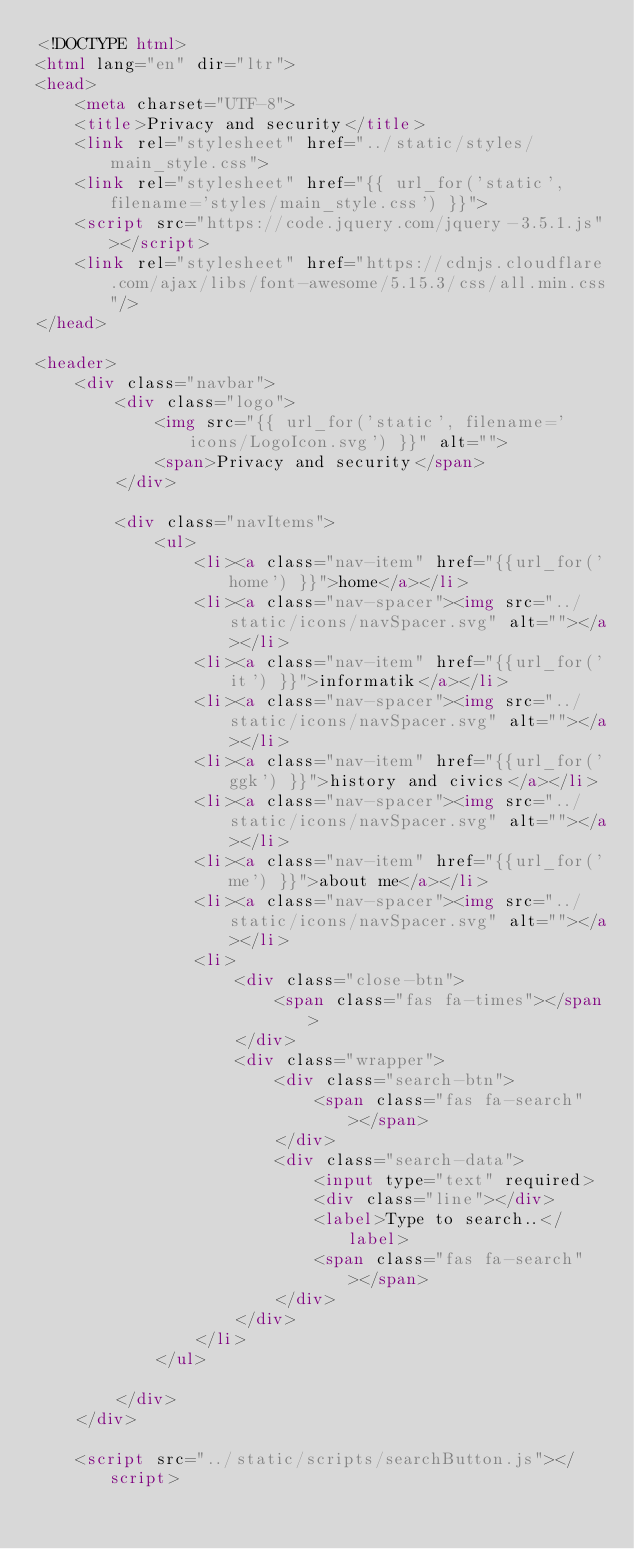Convert code to text. <code><loc_0><loc_0><loc_500><loc_500><_HTML_><!DOCTYPE html>
<html lang="en" dir="ltr">
<head>
    <meta charset="UTF-8">
    <title>Privacy and security</title>
    <link rel="stylesheet" href="../static/styles/main_style.css">
    <link rel="stylesheet" href="{{ url_for('static', filename='styles/main_style.css') }}">
    <script src="https://code.jquery.com/jquery-3.5.1.js"></script>
    <link rel="stylesheet" href="https://cdnjs.cloudflare.com/ajax/libs/font-awesome/5.15.3/css/all.min.css"/>
</head>

<header>
    <div class="navbar">
        <div class="logo">
            <img src="{{ url_for('static', filename='icons/LogoIcon.svg') }}" alt="">
            <span>Privacy and security</span>
        </div>

        <div class="navItems">
            <ul>
                <li><a class="nav-item" href="{{url_for('home') }}">home</a></li>
                <li><a class="nav-spacer"><img src="../static/icons/navSpacer.svg" alt=""></a></li>
                <li><a class="nav-item" href="{{url_for('it') }}">informatik</a></li>
                <li><a class="nav-spacer"><img src="../static/icons/navSpacer.svg" alt=""></a></li>
                <li><a class="nav-item" href="{{url_for('ggk') }}">history and civics</a></li>
                <li><a class="nav-spacer"><img src="../static/icons/navSpacer.svg" alt=""></a></li>
                <li><a class="nav-item" href="{{url_for('me') }}">about me</a></li>
                <li><a class="nav-spacer"><img src="../static/icons/navSpacer.svg" alt=""></a></li>
                <li>
                    <div class="close-btn">
                        <span class="fas fa-times"></span>
                    </div>
                    <div class="wrapper">
                        <div class="search-btn">
                            <span class="fas fa-search"></span>
                        </div>
                        <div class="search-data">
                            <input type="text" required>
                            <div class="line"></div>
                            <label>Type to search..</label>
                            <span class="fas fa-search"></span>
                        </div>
                    </div>
                </li>
            </ul>

        </div>
    </div>

    <script src="../static/scripts/searchButton.js"></script>
</code> 